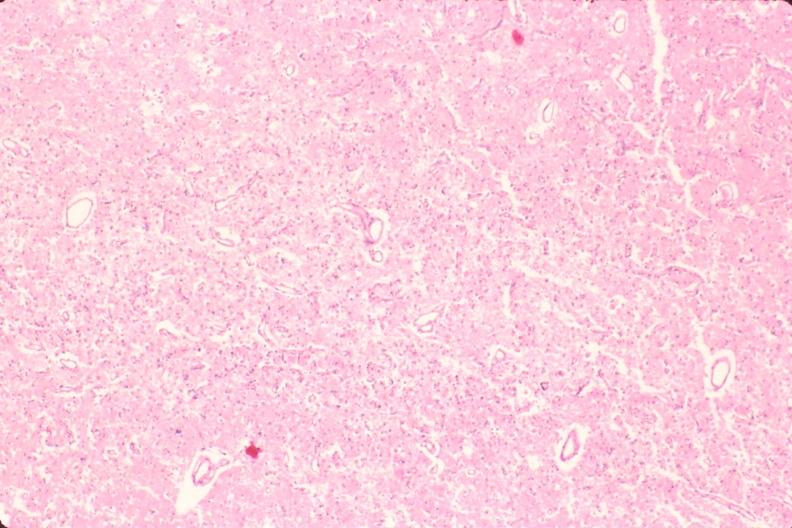s nervous present?
Answer the question using a single word or phrase. Yes 